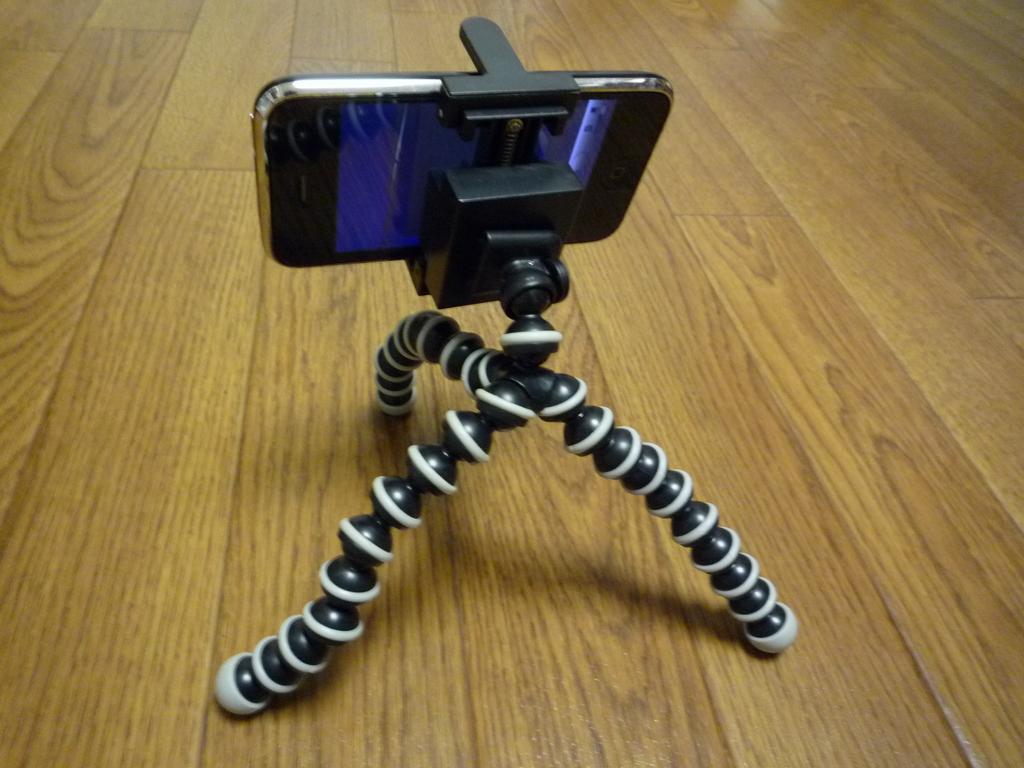Could you give a brief overview of what you see in this image? In this image I can see a camera stand on the floor. I can see a mobile phone. 